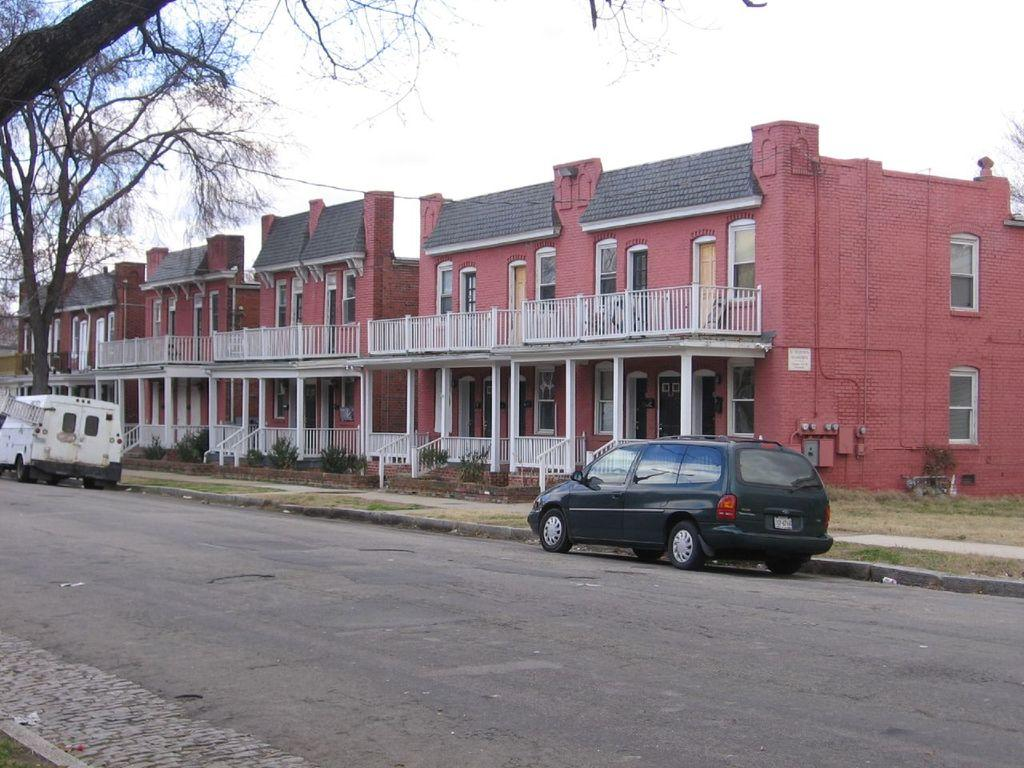What can be seen on the road in the image? There are vehicles on the road in the image. What type of natural elements are visible in the image? There are trees visible in the image. What structures can be seen on the right side of the image? There are buildings on the right side of the image. What is visible at the top of the image? The sky is visible at the top of the image. Can you describe the tail of the animal in the image? There is no animal with a tail present in the image. What type of shade is provided by the trees in the image? The image does not show any specific shade provided by the trees; it only shows the trees themselves. 